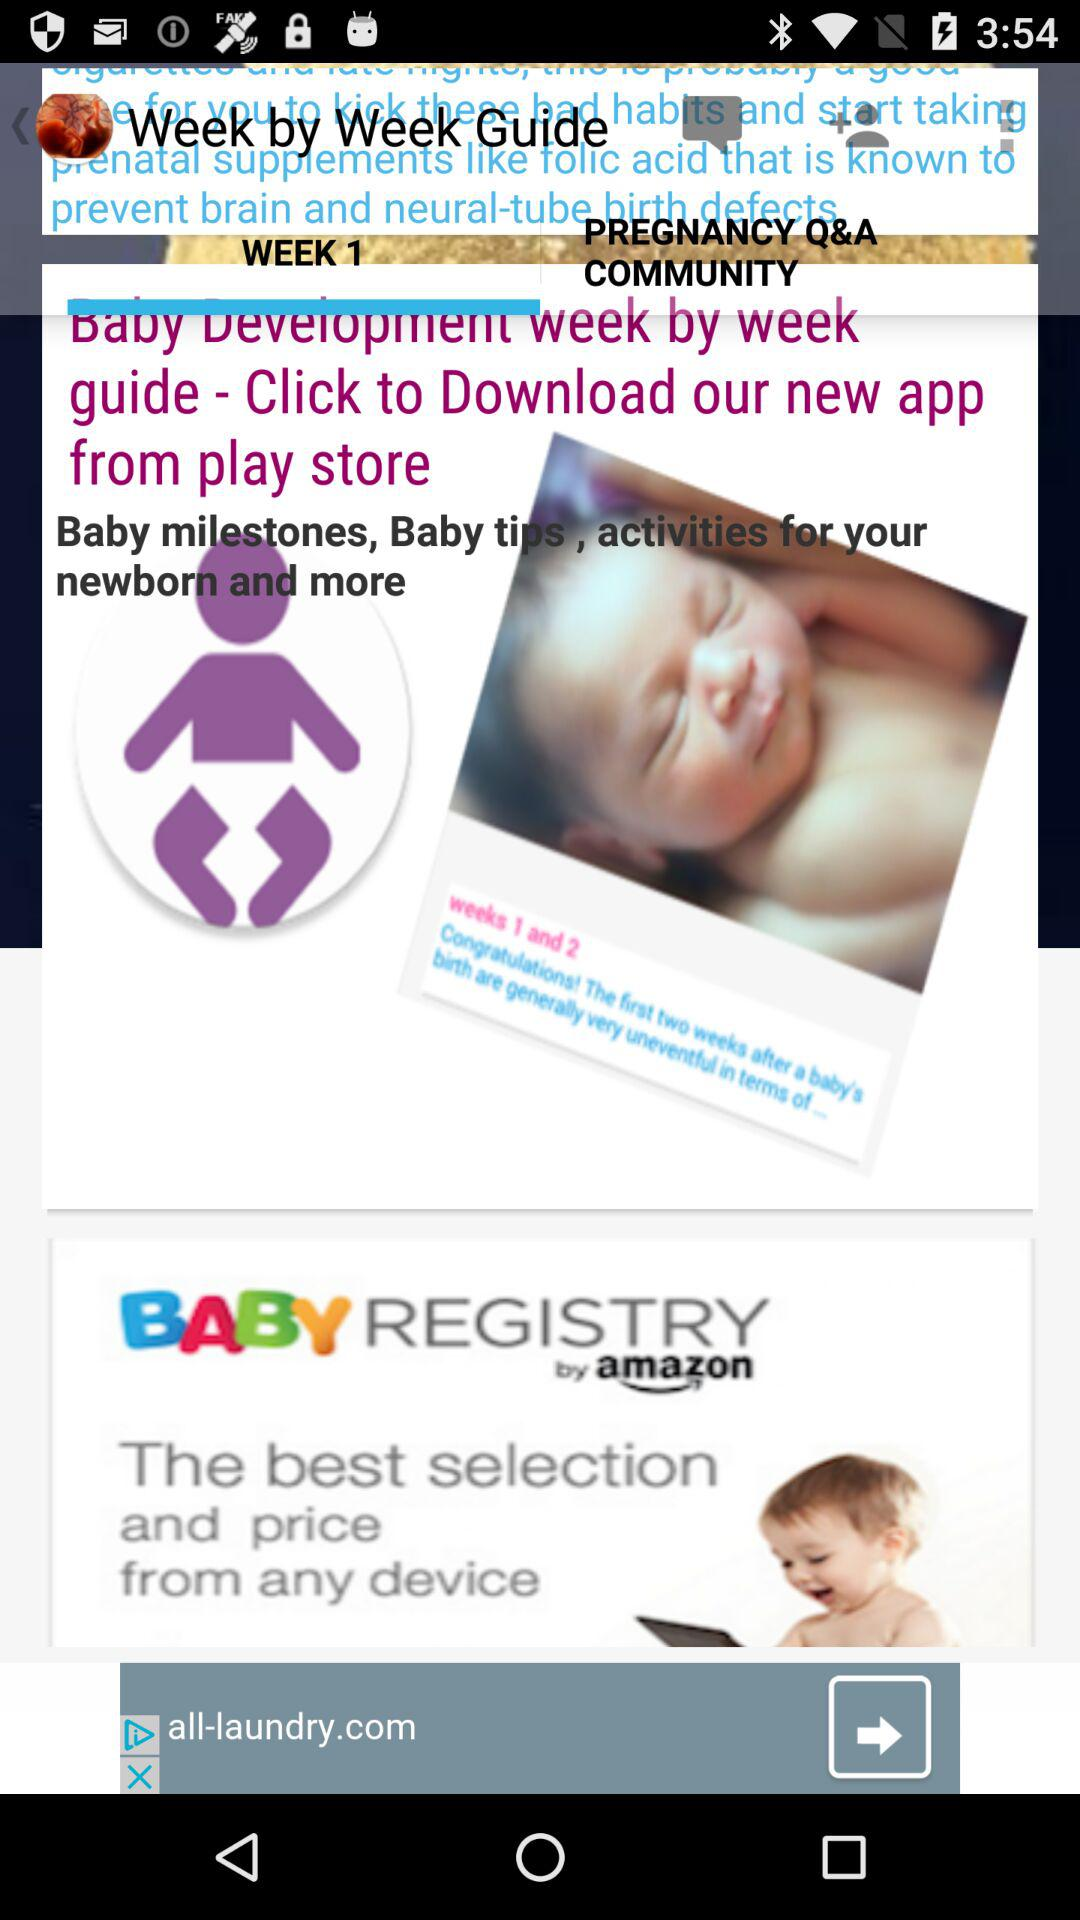Which tab is selected? The selected tab is "WEEK 1". 